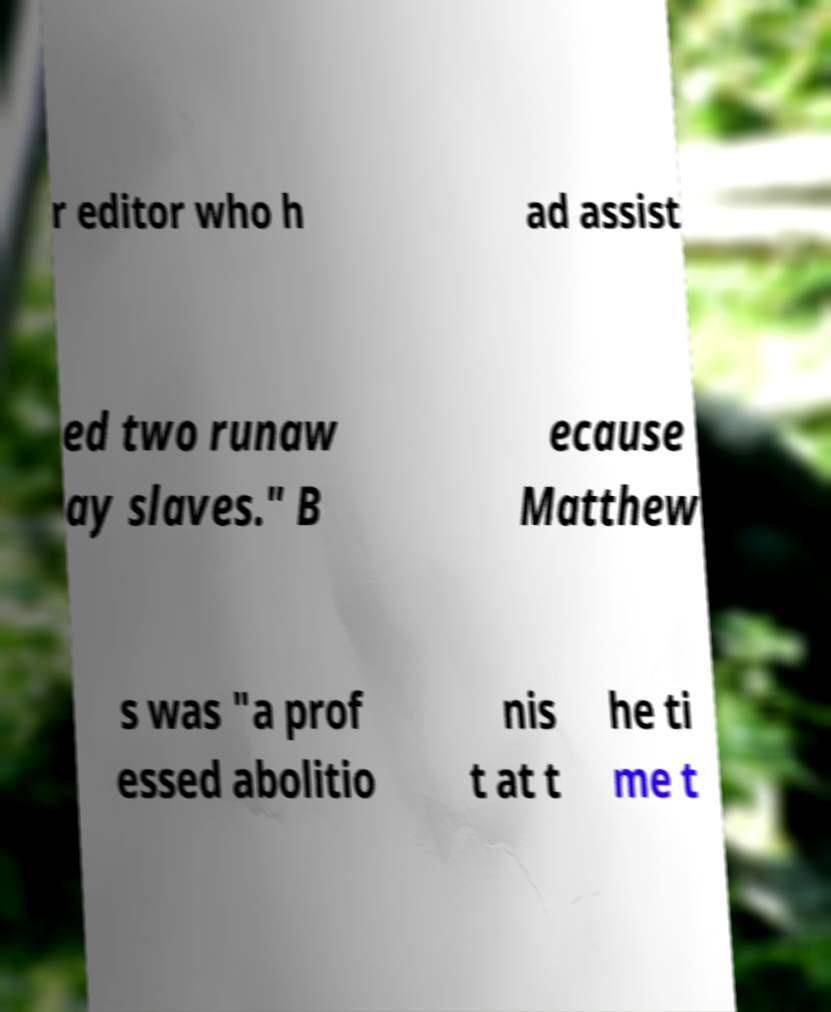Could you assist in decoding the text presented in this image and type it out clearly? r editor who h ad assist ed two runaw ay slaves." B ecause Matthew s was "a prof essed abolitio nis t at t he ti me t 